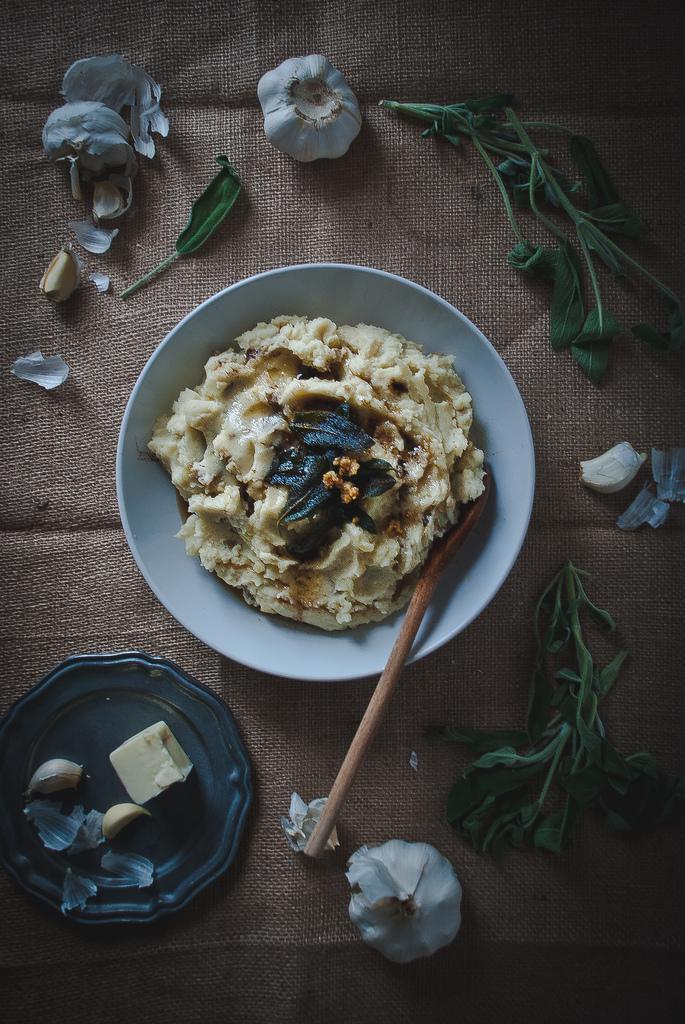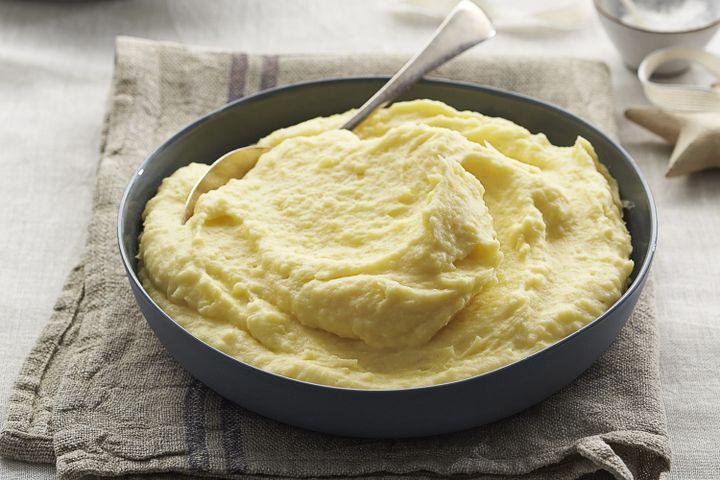The first image is the image on the left, the second image is the image on the right. For the images displayed, is the sentence "The mashed potatoes on the right have a spoon handle visibly sticking out of them" factually correct? Answer yes or no. Yes. 